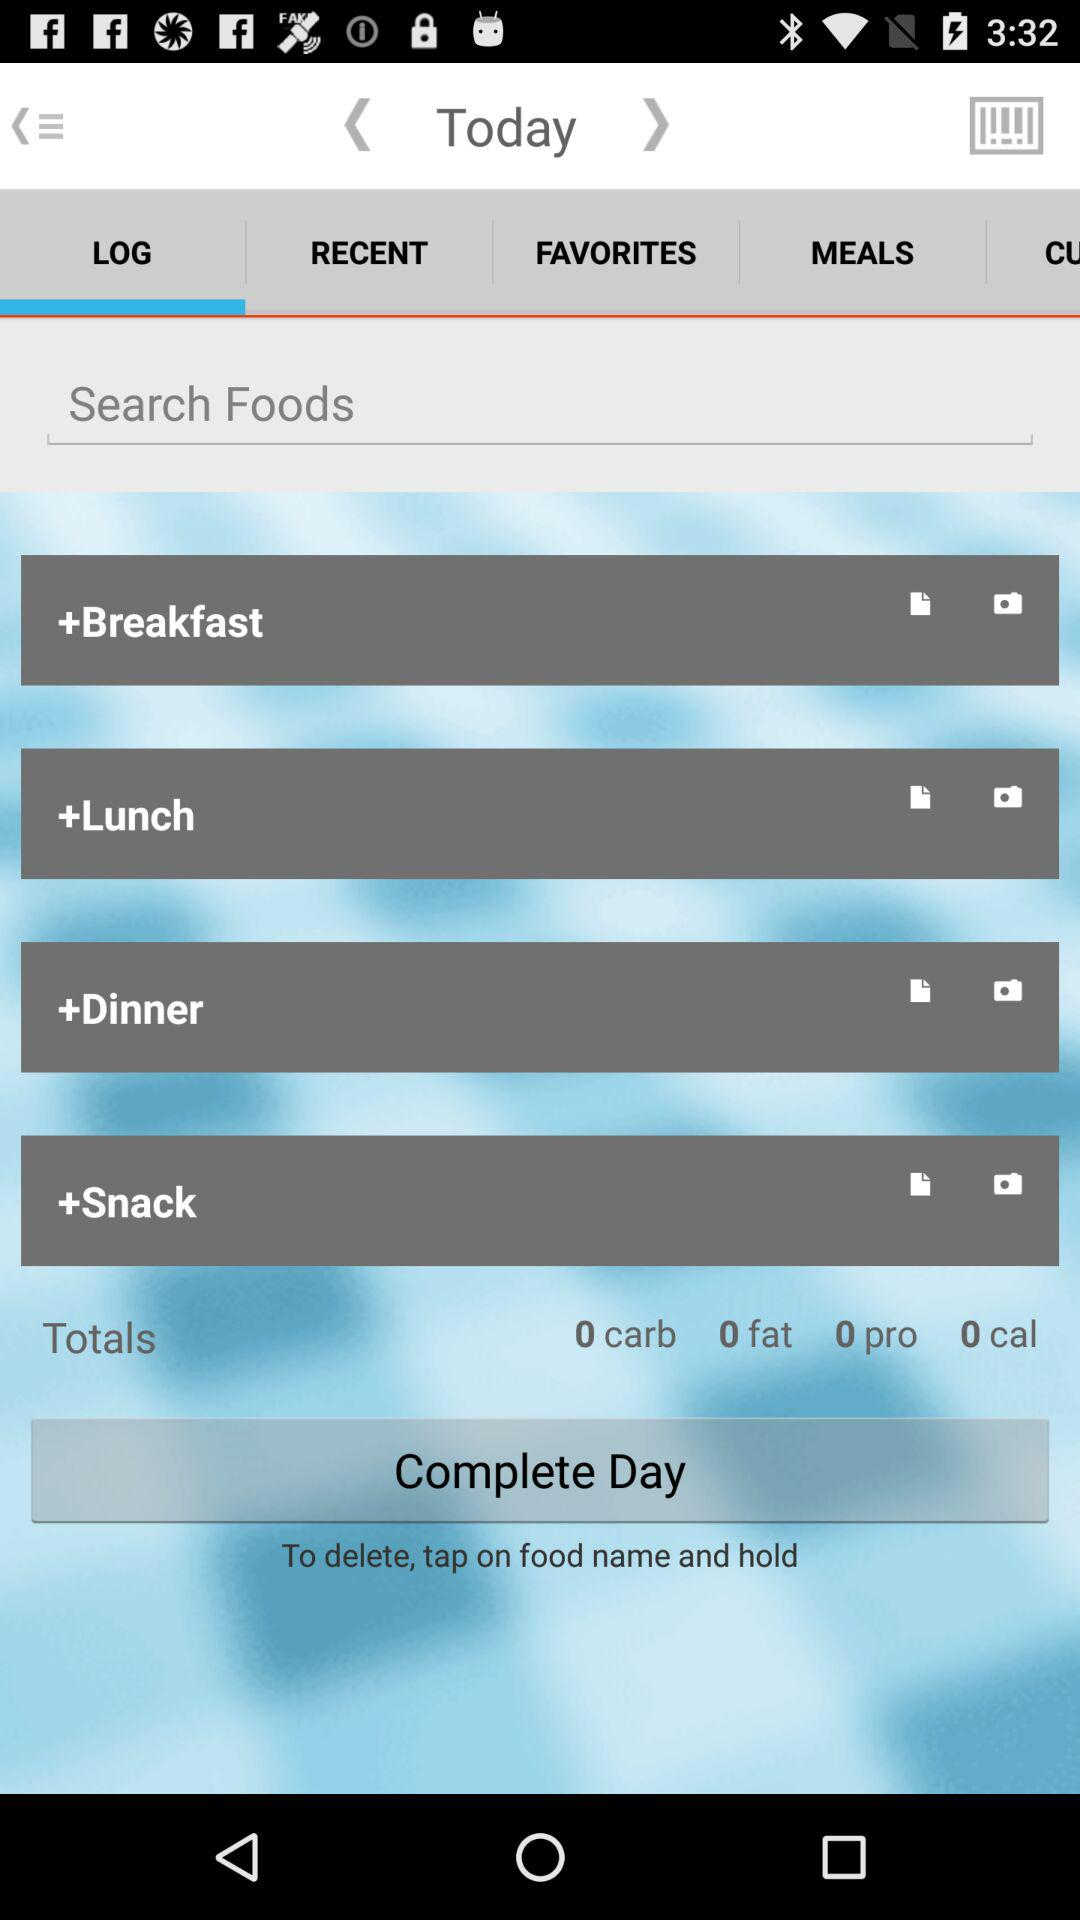How many meals have been added to the day?
Answer the question using a single word or phrase. 4 